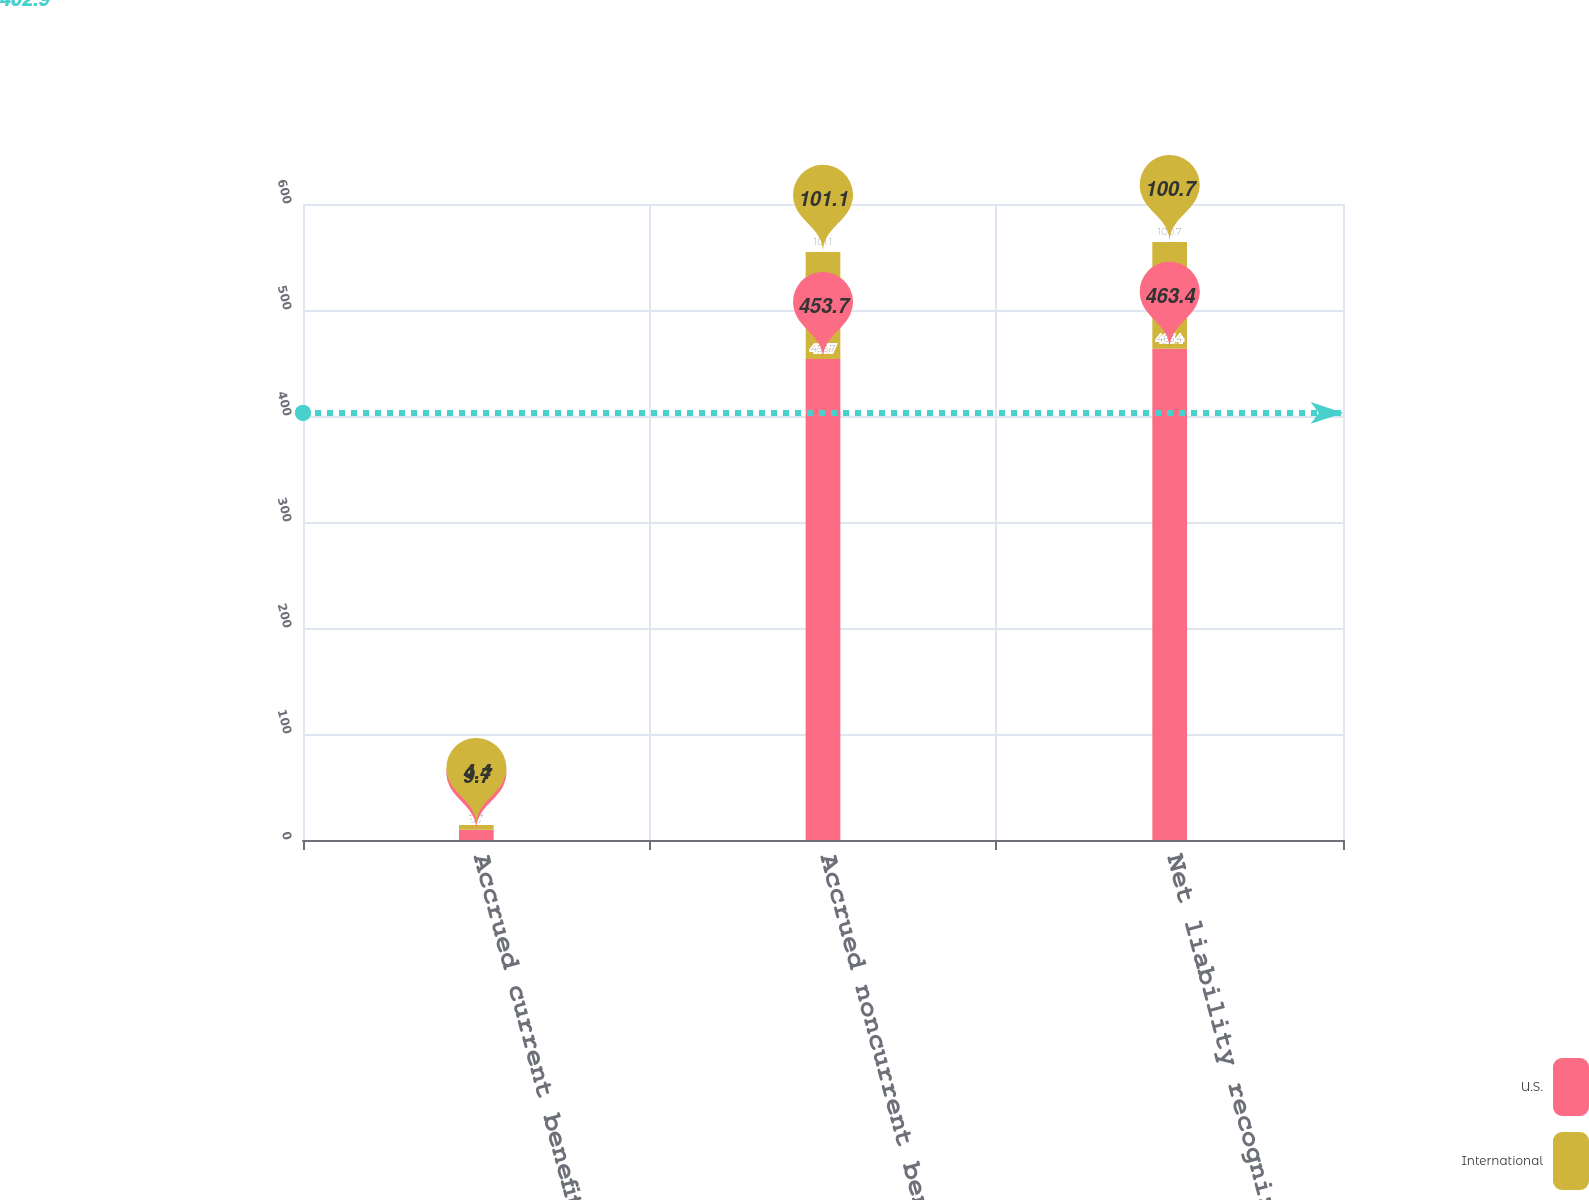<chart> <loc_0><loc_0><loc_500><loc_500><stacked_bar_chart><ecel><fcel>Accrued current benefit cost<fcel>Accrued noncurrent benefit<fcel>Net liability recognized in<nl><fcel>U.S.<fcel>9.7<fcel>453.7<fcel>463.4<nl><fcel>International<fcel>4.4<fcel>101.1<fcel>100.7<nl></chart> 